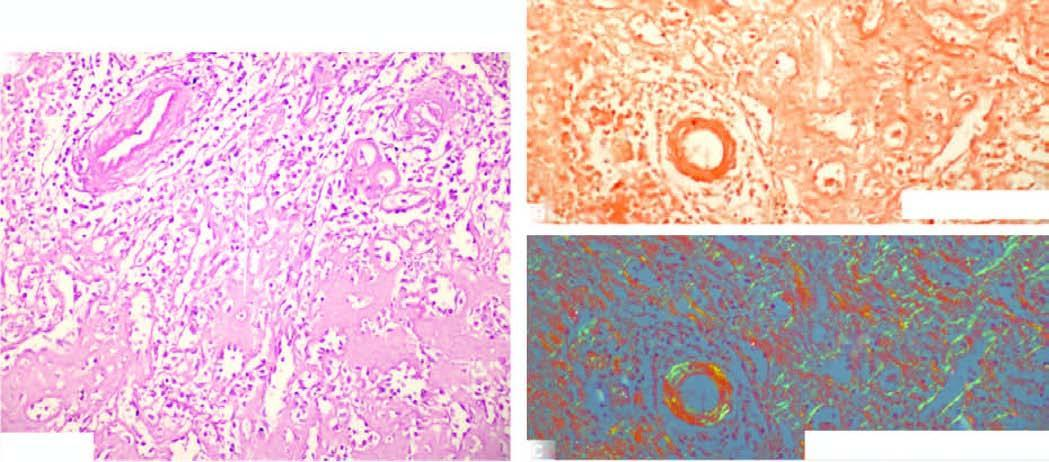what is seen in the red pulp causing atrophy of while pulp?
Answer the question using a single word or phrase. Pink acellular amyloid material 